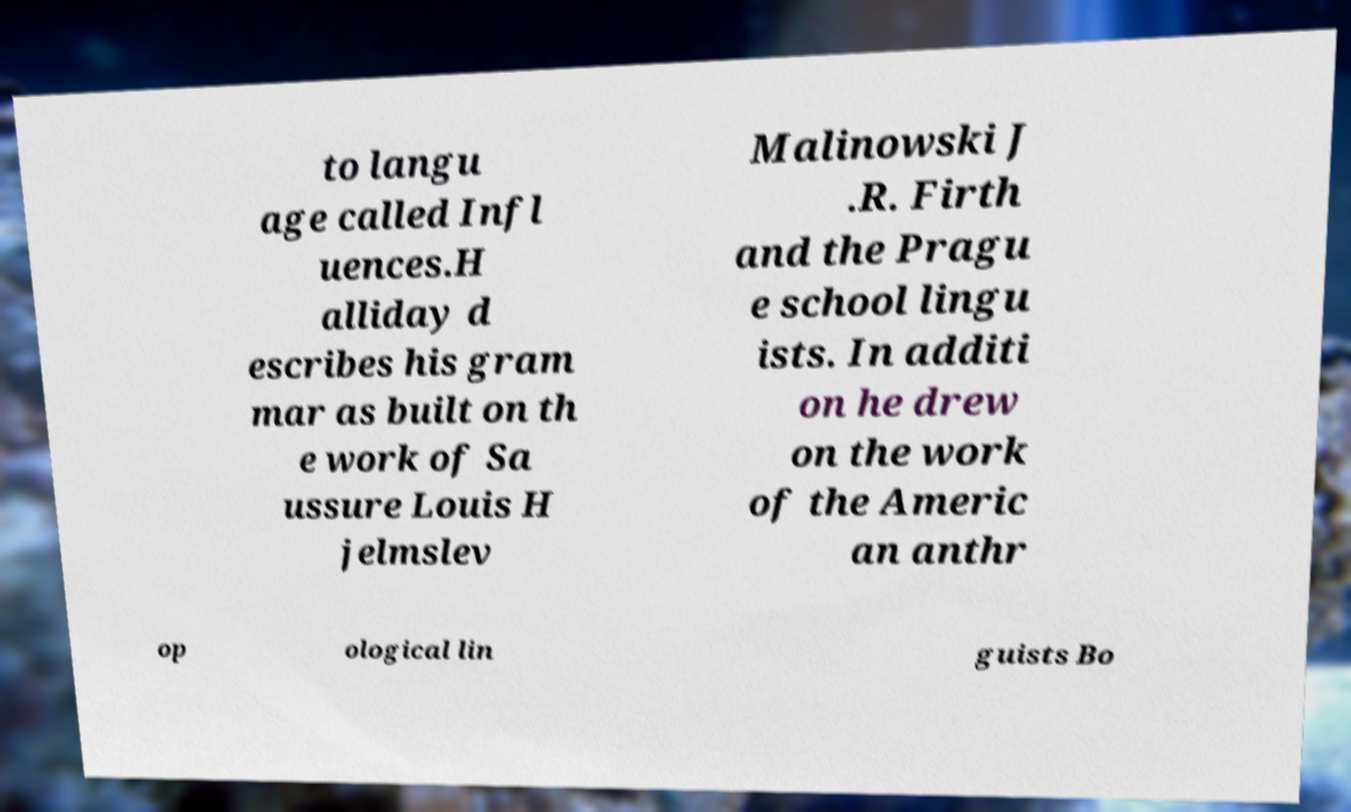Can you accurately transcribe the text from the provided image for me? to langu age called Infl uences.H alliday d escribes his gram mar as built on th e work of Sa ussure Louis H jelmslev Malinowski J .R. Firth and the Pragu e school lingu ists. In additi on he drew on the work of the Americ an anthr op ological lin guists Bo 